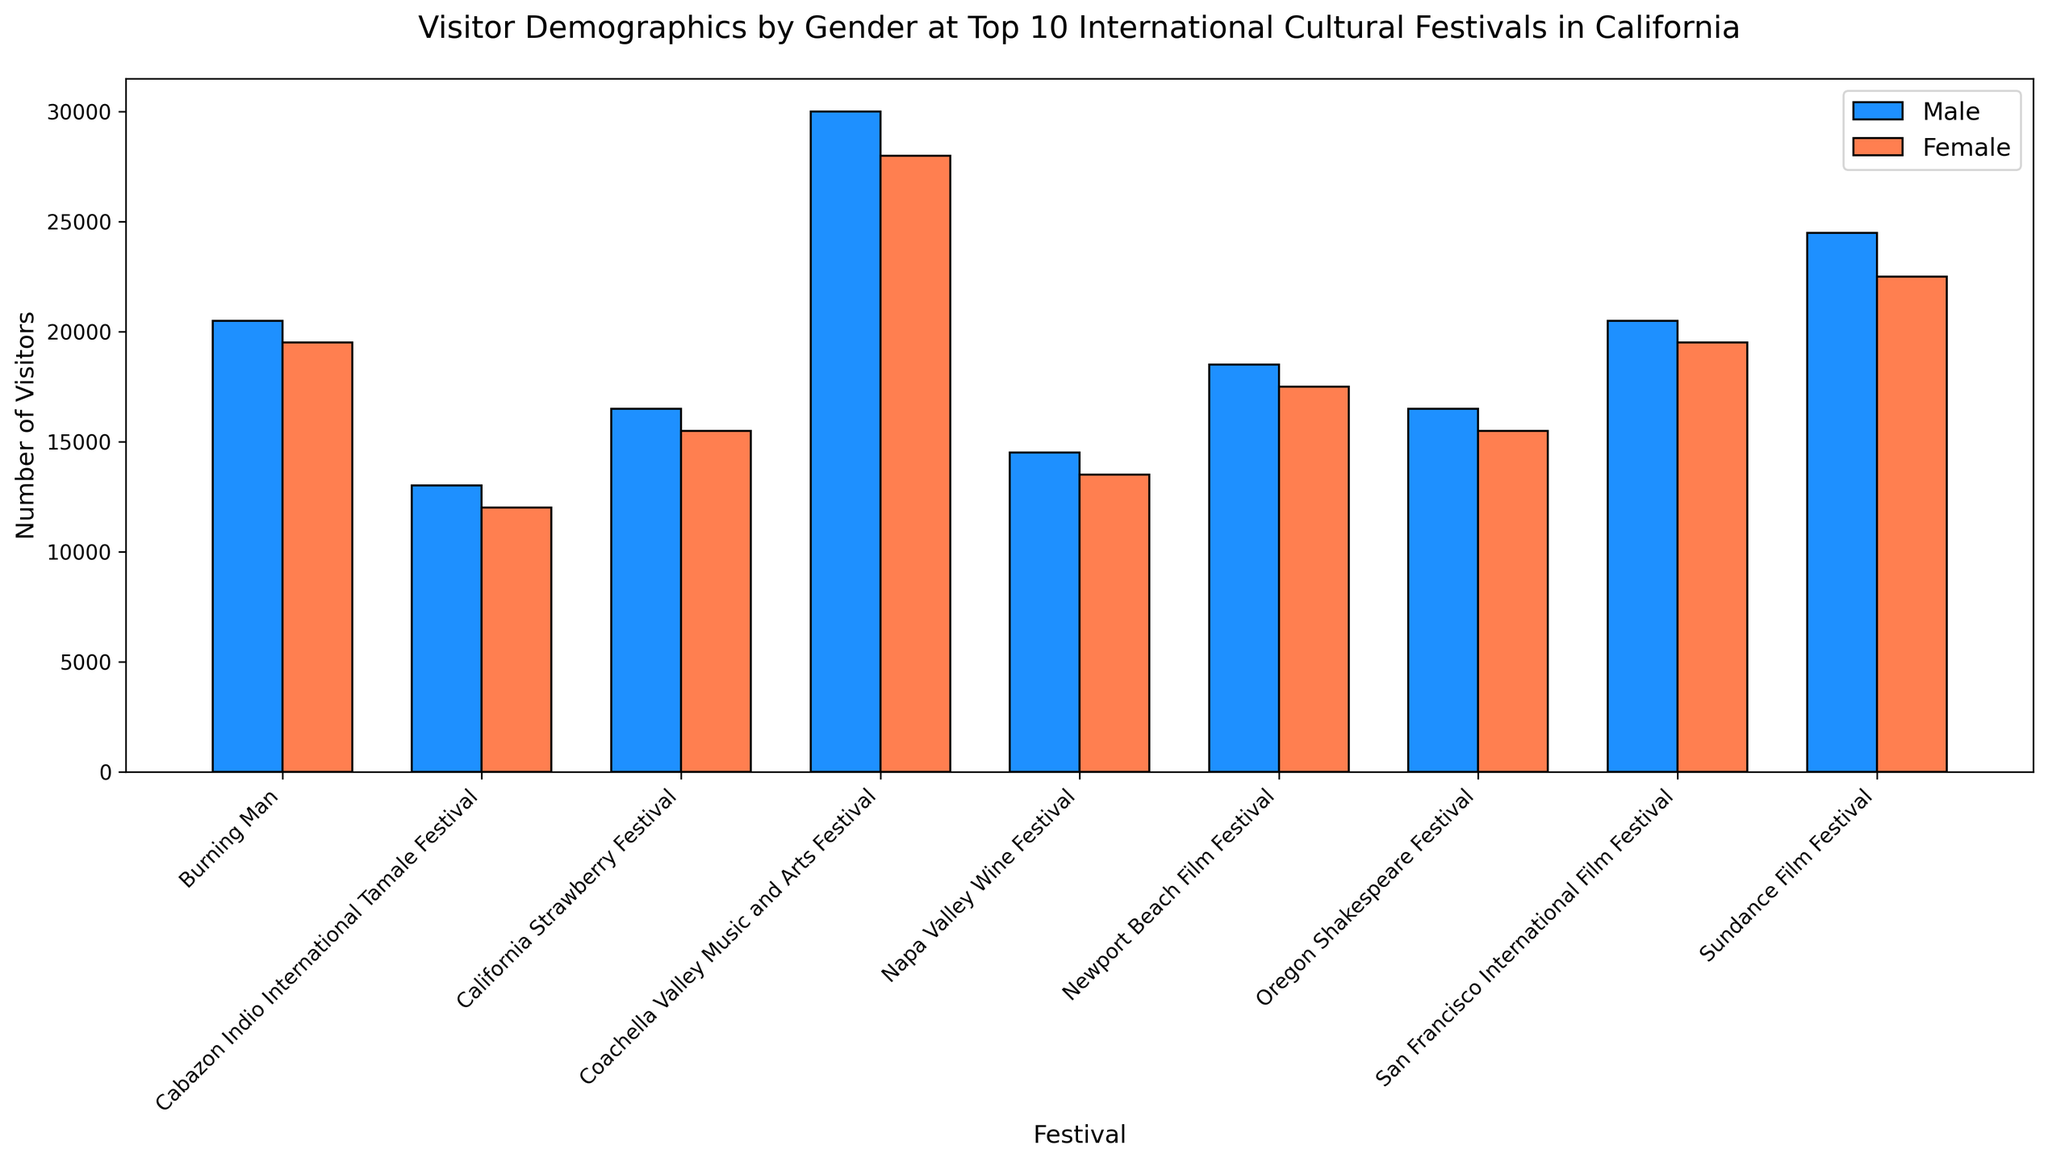What's the total number of male visitors across all festivals? Sum the visitor counts for males in each festival: 
15000 (Coachella) + 12000 (Sundance) + 8000 (Oregon) + 10000 (Burning Man) + 7000 (Napa Valley) + 9000 (Newport) + 8000 (Strawberry) + 10000 (San Francisco) + 6000 (Tamale) = 90000
Answer: 90000 Which festival has the highest number of female visitors? The female visitor counts for each festival are:
14000 (Coachella), 11000 (Sundance), 7500 (Oregon), 9500 (Burning Man), 6500 (Napa Valley), 8500 (Newport), 7500 (Strawberry), 9500 (San Francisco), 5500 (Tamale). 
Among these, Coachella Valley Music and Arts Festival has the highest number with 14000.
Answer: Coachella Valley Music and Arts Festival Are there more males or females at the Sundance Film Festival? Compare the counts: Male visitors at Sundance are 12000, female visitors are 11000. There are more male visitors at Sundance.
Answer: Males What's the difference in the number of visitors between the Oregon Shakespeare Festival and the Newport Beach Film Festival? Sum the male and female visitor counts for both festivals: 
Oregon: 8000 (Male) + 7500 (Female) = 15500; Newport: 9000 (Male) + 8500 (Female) = 17500; 
The difference is 17500 - 15500 = 2000.
Answer: 2000 What's the average number of female visitors at the three film festivals (Sundance, Newport Beach, San Francisco)? Female visitor counts: 11000 (Sundance), 8500 (Newport Beach), 9500 (San Francisco); 
Sum = 11000 + 8500 + 9500 = 29000; 
Average = 29000 / 3 = 9666.67
Answer: 9666.67 Is the number of female visitors at Coachella Valley Music and Arts Festival greater than the combined total of male and female visitors at the Cabazon Indio International Tamale Festival? Compare the counts: 
Female visitors at Coachella = 14000; 
Combined total for Tamale: 6000 (Male) + 5500 (Female) = 11500. 
14000 > 11500.
Answer: Yes What's the ratio of male to female visitors at Burning Man? Male visitors at Burning Man = 10000, female = 9500; 
Ratio = 10000 / 9500; Simplified, it's approximately 1.05.
Answer: 1.05 What's the combined total number of visitors at the Napa Valley Wine Festival and the San Francisco International Film Festival? Sum the visitors for both festivals: 
Napa Valley: 7000 (Male) + 6500 (Female) = 13500; 
San Francisco: 10000 (Male) + 9500 (Female) = 19500;
Combined total = 13500 + 19500 = 33000.
Answer: 33000 